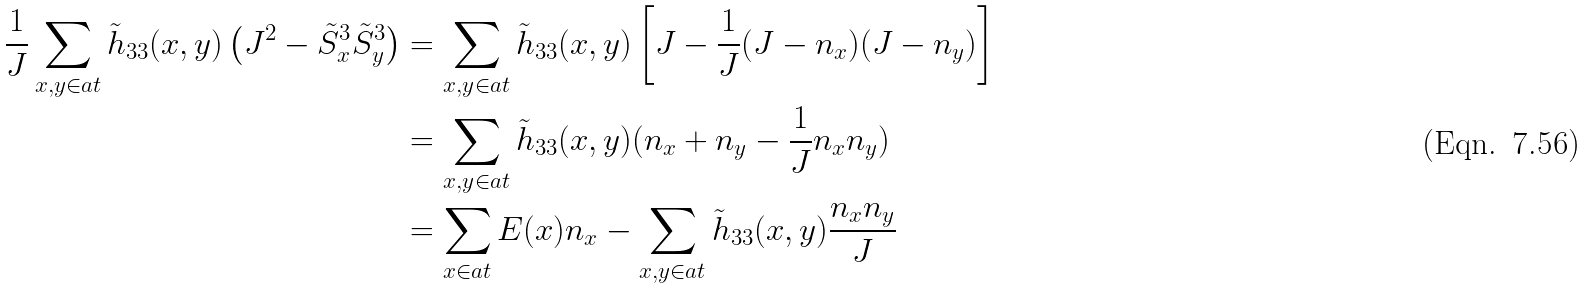<formula> <loc_0><loc_0><loc_500><loc_500>\frac { 1 } { J } \sum _ { x , y \in \L a t } \tilde { h } _ { 3 3 } ( x , y ) \left ( J ^ { 2 } - \tilde { S } ^ { 3 } _ { x } \tilde { S } ^ { 3 } _ { y } \right ) & = \sum _ { x , y \in \L a t } \tilde { h } _ { 3 3 } ( x , y ) \left [ J - \frac { 1 } { J } ( J - n _ { x } ) ( J - n _ { y } ) \right ] \\ & = \sum _ { x , y \in \L a t } \tilde { h } _ { 3 3 } ( x , y ) ( n _ { x } + n _ { y } - \frac { 1 } { J } n _ { x } n _ { y } ) \\ & = \sum _ { x \in \L a t } E ( x ) n _ { x } - \sum _ { x , y \in \L a t } \tilde { h } _ { 3 3 } ( x , y ) \frac { n _ { x } n _ { y } } J</formula> 